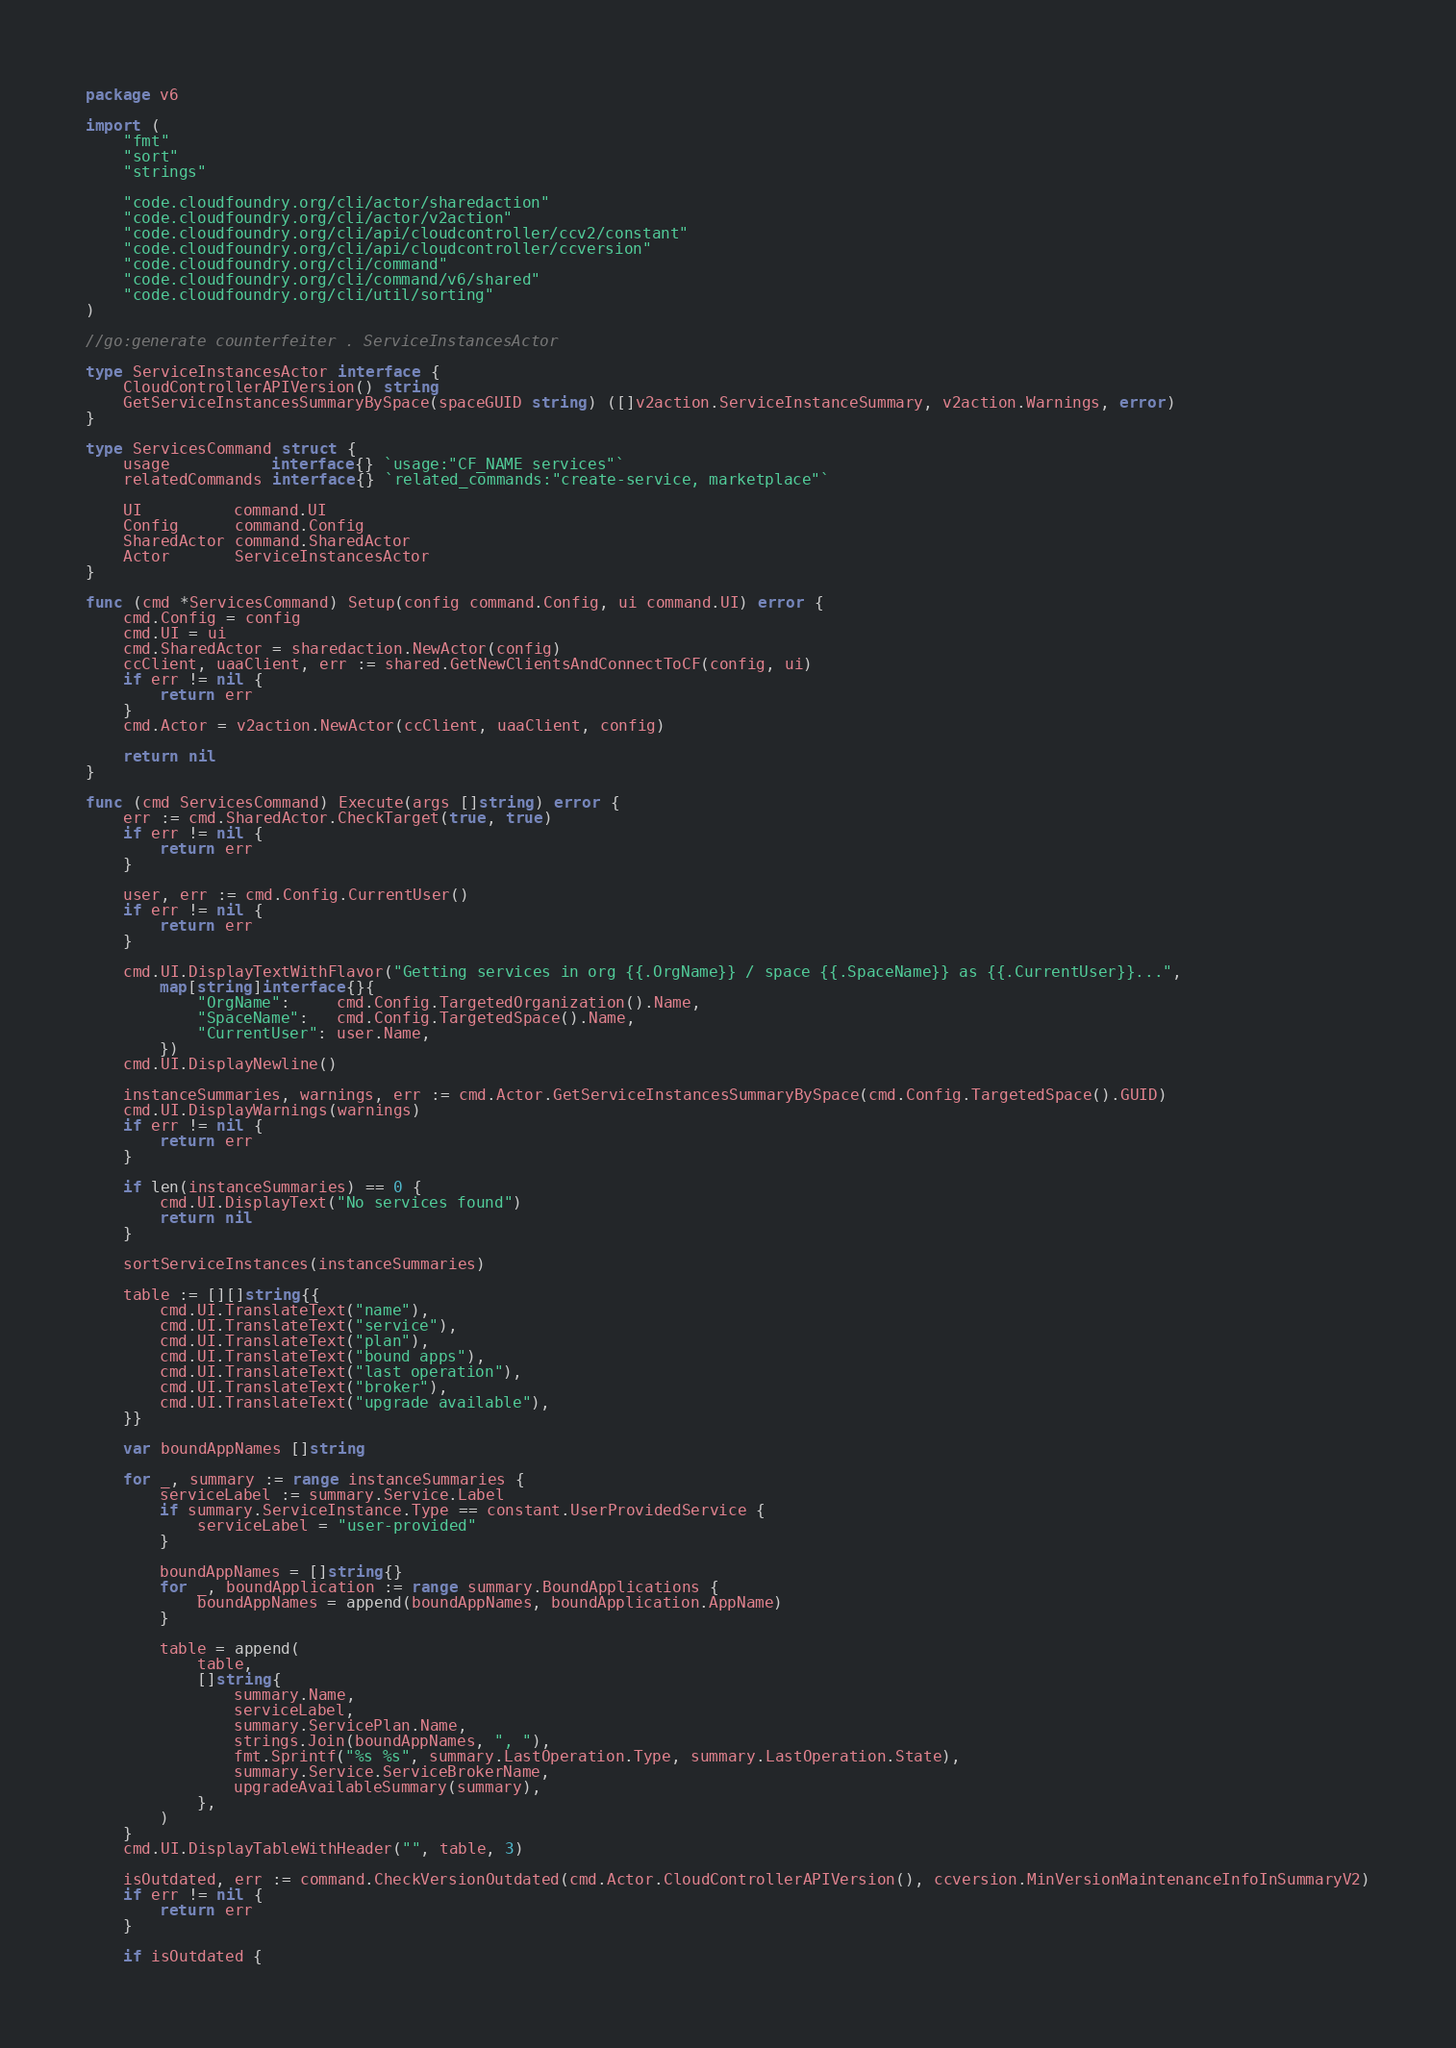Convert code to text. <code><loc_0><loc_0><loc_500><loc_500><_Go_>package v6

import (
	"fmt"
	"sort"
	"strings"

	"code.cloudfoundry.org/cli/actor/sharedaction"
	"code.cloudfoundry.org/cli/actor/v2action"
	"code.cloudfoundry.org/cli/api/cloudcontroller/ccv2/constant"
	"code.cloudfoundry.org/cli/api/cloudcontroller/ccversion"
	"code.cloudfoundry.org/cli/command"
	"code.cloudfoundry.org/cli/command/v6/shared"
	"code.cloudfoundry.org/cli/util/sorting"
)

//go:generate counterfeiter . ServiceInstancesActor

type ServiceInstancesActor interface {
	CloudControllerAPIVersion() string
	GetServiceInstancesSummaryBySpace(spaceGUID string) ([]v2action.ServiceInstanceSummary, v2action.Warnings, error)
}

type ServicesCommand struct {
	usage           interface{} `usage:"CF_NAME services"`
	relatedCommands interface{} `related_commands:"create-service, marketplace"`

	UI          command.UI
	Config      command.Config
	SharedActor command.SharedActor
	Actor       ServiceInstancesActor
}

func (cmd *ServicesCommand) Setup(config command.Config, ui command.UI) error {
	cmd.Config = config
	cmd.UI = ui
	cmd.SharedActor = sharedaction.NewActor(config)
	ccClient, uaaClient, err := shared.GetNewClientsAndConnectToCF(config, ui)
	if err != nil {
		return err
	}
	cmd.Actor = v2action.NewActor(ccClient, uaaClient, config)

	return nil
}

func (cmd ServicesCommand) Execute(args []string) error {
	err := cmd.SharedActor.CheckTarget(true, true)
	if err != nil {
		return err
	}

	user, err := cmd.Config.CurrentUser()
	if err != nil {
		return err
	}

	cmd.UI.DisplayTextWithFlavor("Getting services in org {{.OrgName}} / space {{.SpaceName}} as {{.CurrentUser}}...",
		map[string]interface{}{
			"OrgName":     cmd.Config.TargetedOrganization().Name,
			"SpaceName":   cmd.Config.TargetedSpace().Name,
			"CurrentUser": user.Name,
		})
	cmd.UI.DisplayNewline()

	instanceSummaries, warnings, err := cmd.Actor.GetServiceInstancesSummaryBySpace(cmd.Config.TargetedSpace().GUID)
	cmd.UI.DisplayWarnings(warnings)
	if err != nil {
		return err
	}

	if len(instanceSummaries) == 0 {
		cmd.UI.DisplayText("No services found")
		return nil
	}

	sortServiceInstances(instanceSummaries)

	table := [][]string{{
		cmd.UI.TranslateText("name"),
		cmd.UI.TranslateText("service"),
		cmd.UI.TranslateText("plan"),
		cmd.UI.TranslateText("bound apps"),
		cmd.UI.TranslateText("last operation"),
		cmd.UI.TranslateText("broker"),
		cmd.UI.TranslateText("upgrade available"),
	}}

	var boundAppNames []string

	for _, summary := range instanceSummaries {
		serviceLabel := summary.Service.Label
		if summary.ServiceInstance.Type == constant.UserProvidedService {
			serviceLabel = "user-provided"
		}

		boundAppNames = []string{}
		for _, boundApplication := range summary.BoundApplications {
			boundAppNames = append(boundAppNames, boundApplication.AppName)
		}

		table = append(
			table,
			[]string{
				summary.Name,
				serviceLabel,
				summary.ServicePlan.Name,
				strings.Join(boundAppNames, ", "),
				fmt.Sprintf("%s %s", summary.LastOperation.Type, summary.LastOperation.State),
				summary.Service.ServiceBrokerName,
				upgradeAvailableSummary(summary),
			},
		)
	}
	cmd.UI.DisplayTableWithHeader("", table, 3)

	isOutdated, err := command.CheckVersionOutdated(cmd.Actor.CloudControllerAPIVersion(), ccversion.MinVersionMaintenanceInfoInSummaryV2)
	if err != nil {
		return err
	}

	if isOutdated {</code> 